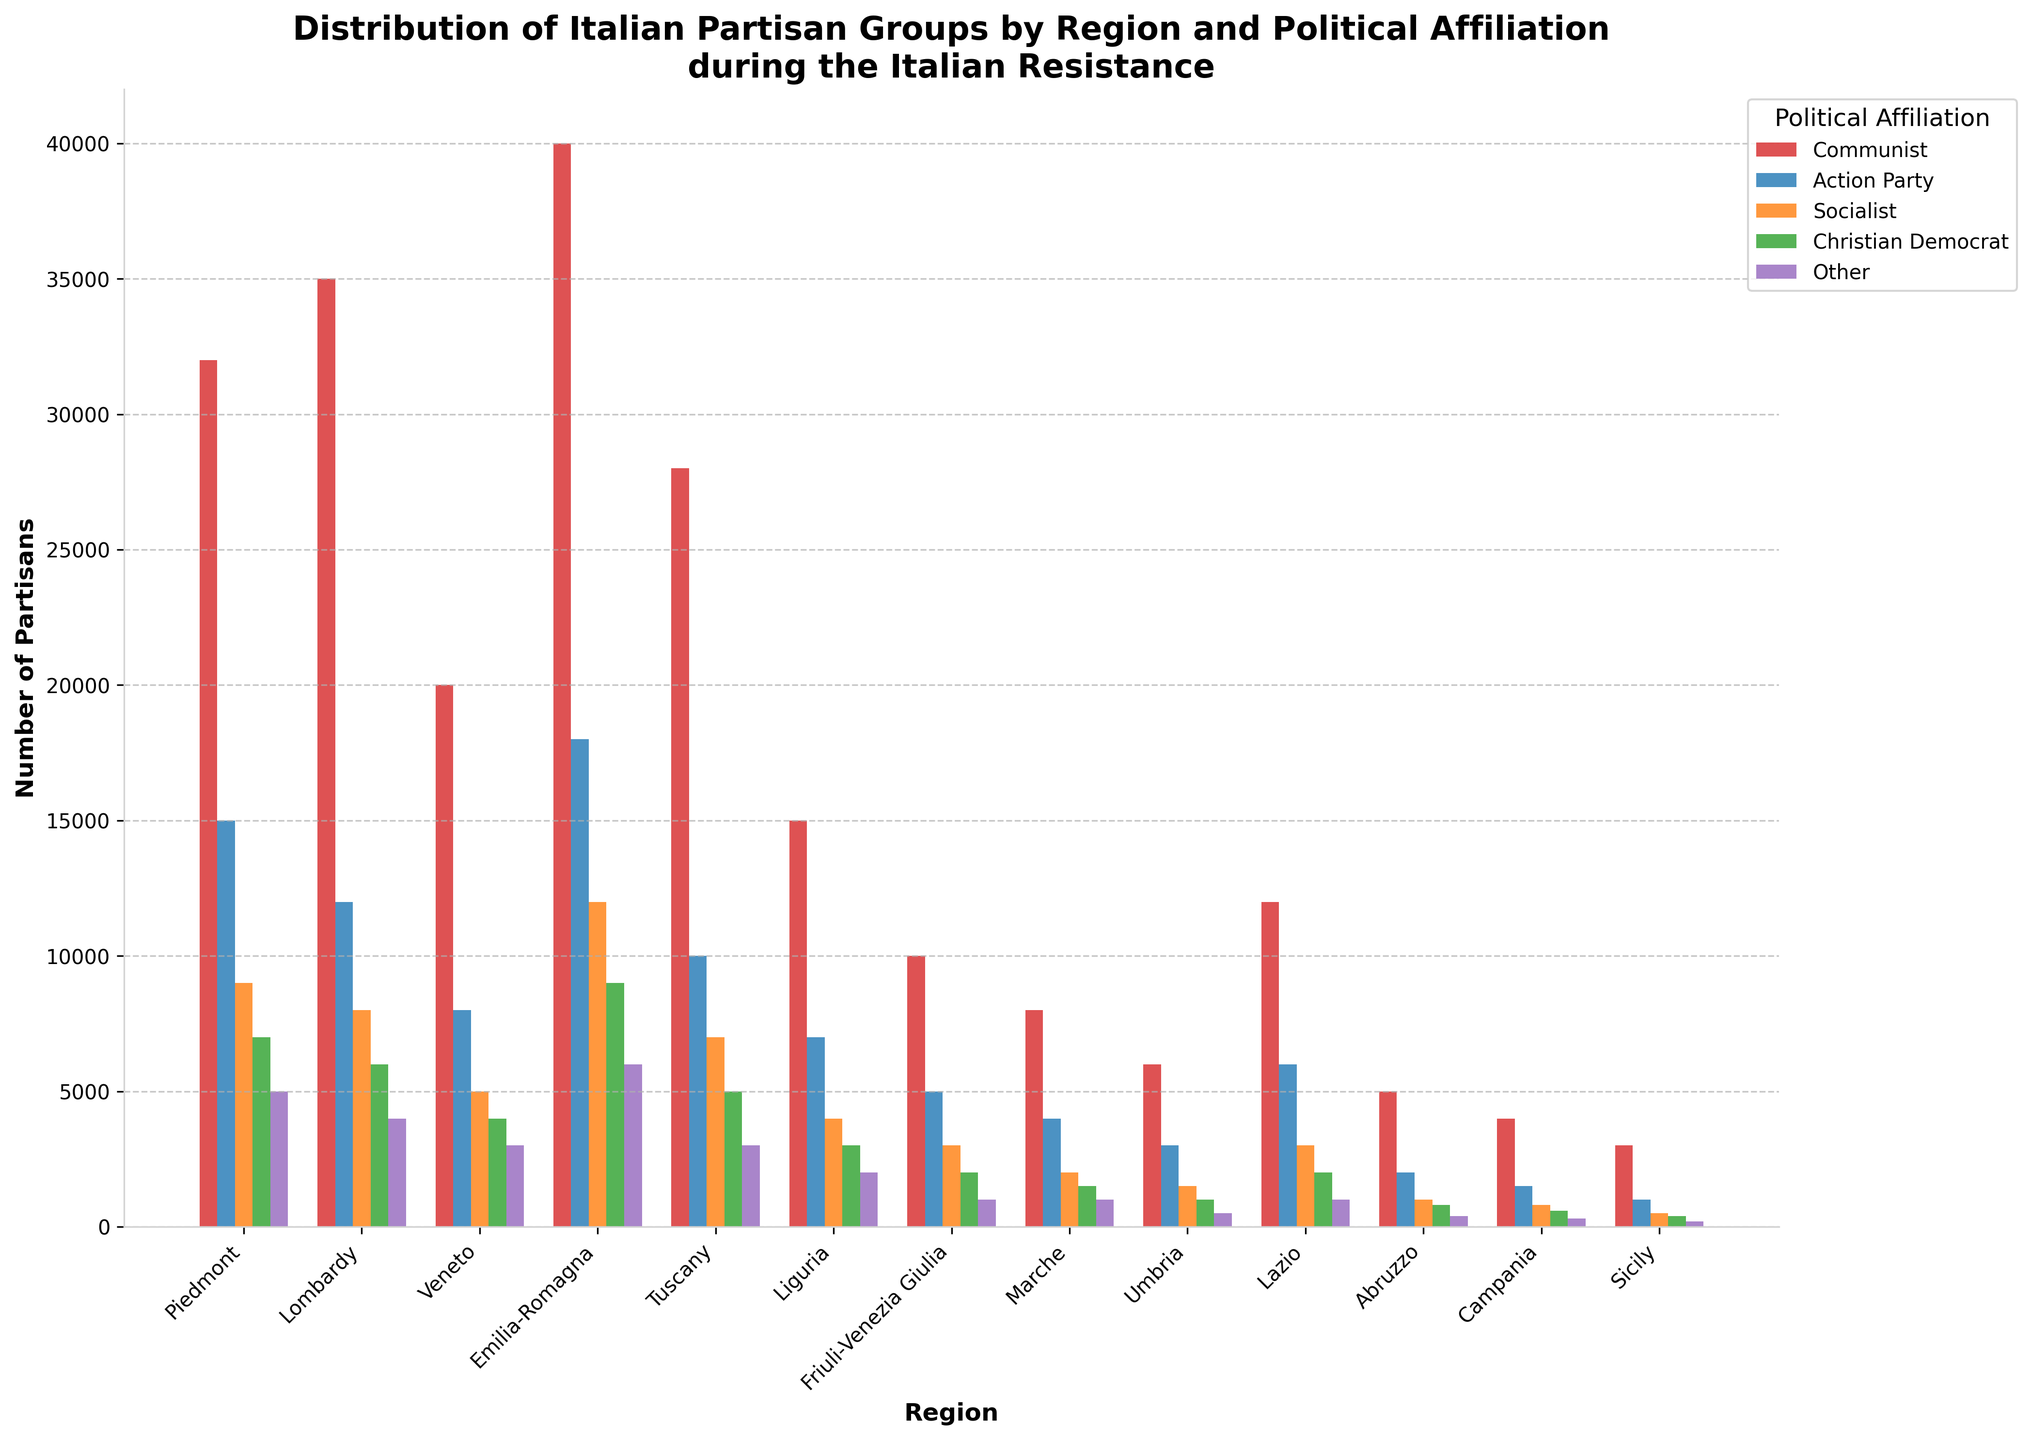Which region has the highest number of Communist partisans? Observing the heights of the red bars representing Communist partisans, the tallest bar is in Emilia-Romagna.
Answer: Emilia-Romagna Which political affiliation has the least partisans in Sicily? Looking at the bar colors in Sicily, the shortest bar corresponds to the "Other" affiliation.
Answer: Other How many total partisans are there in Piedmont? Sum the heights of all bars in Piedmont: 32000 (Communist) + 15000 (Action Party) + 9000 (Socialist) + 7000 (Christian Democrat) + 5000 (Other). The total is 68000.
Answer: 68000 Which political affiliation is the least represented in Lazio? Looking at the bar lengths in Lazio, the shortest bar is for the "Other" affiliation.
Answer: Other How many more Communist partisans are there in Emilia-Romagna compared to Lombardy? Subtract the number of Communist partisans in Lombardy from Emilia-Romagna: 40000 (Emilia-Romagna) - 35000 (Lombardy). The result is 5000.
Answer: 5000 In which region is the "Action Party" affiliation most prominent relative to other affiliations within the same region? Compare the "Action Party" bar heights across regions, and the region where this bar is tallest relative to other bars in the same region is evident. Emilia-Romagna stands out with the highest value.
Answer: Emilia-Romagna Which region has the highest overall number of partisans? Sum the total number of partisans across all affiliations for each region and compare. Emilia-Romagna has the highest sum.
Answer: Emilia-Romagna What is the average number of Socialists across all regions? Sum the number of Socialists in all regions and divide by the number of regions: (9000 + 8000 + 5000 + 12000 + 7000 + 4000 + 3000 + 2000 + 1500 + 3000 + 1000 + 800 + 500) / 13. The total sum is 61000, so the average is 61000 / 13.
Answer: 4692 How does the number of Christian Democrat partisans in Veneto compare to those in Tuscany? The number of Christian Democrat partisans in Veneto is 4000, whereas in Tuscany it is 5000. Thus, Veneto has 1000 fewer Christian Democrat partisans compared to Tuscany.
Answer: 1000 fewer Which political affiliation has the second most partisans in Piedmont? Look at the second tallest bar in the Piedmont region, which corresponds to the "Action Party" affiliation with 15000 partisans.
Answer: Action Party 